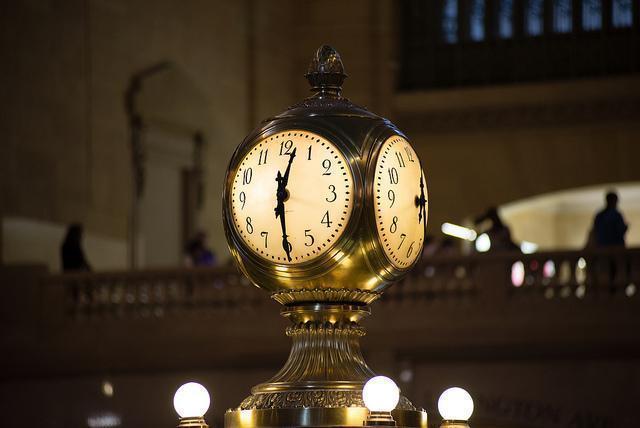If the clock is showing times in the PM how many hours ago did the New York Stock Exchange open?
Pick the correct solution from the four options below to address the question.
Options: One, three, four, six. Three. 